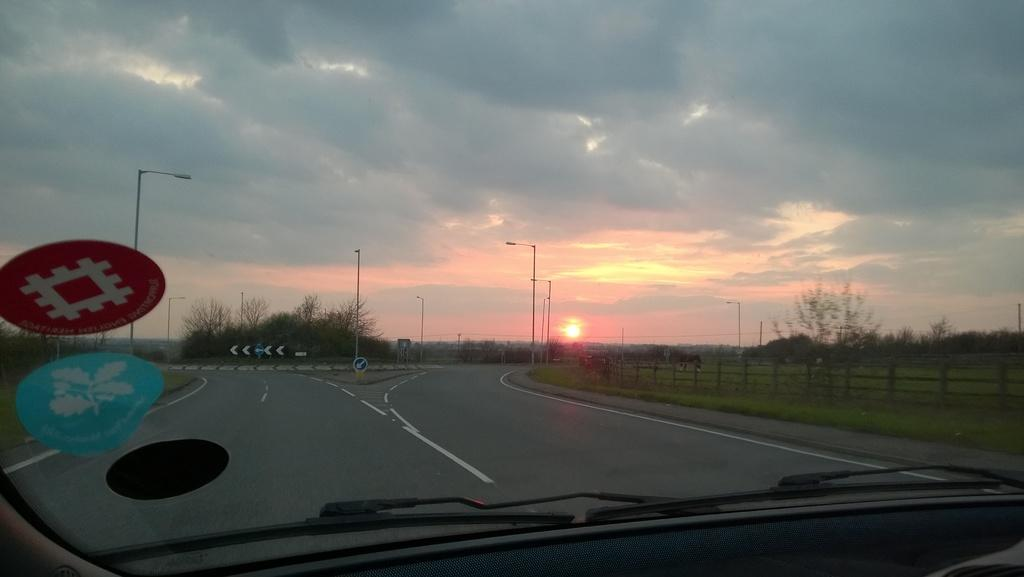What is the main subject of the image? The main subject of the image is a vehicle windshield. What can be seen through the windshield? The road is visible through the windshield. What other objects are present in the image? Sign boards, light poles, a fence, grass, trees, and the sky are visible in the image. Can you describe the sky in the image? The sky is visible in the image, and it contains clouds and the sun. How many pigs are visible in the image? There are no pigs present in the image. What is the profit margin of the vehicle in the image? The image does not provide information about the profit margin of the vehicle. 